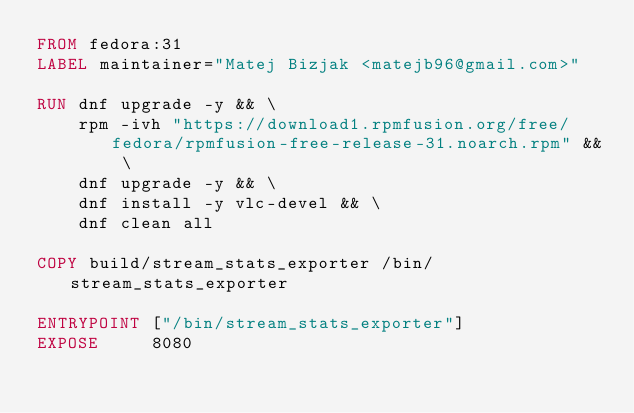Convert code to text. <code><loc_0><loc_0><loc_500><loc_500><_Dockerfile_>FROM fedora:31
LABEL maintainer="Matej Bizjak <matejb96@gmail.com>"

RUN dnf upgrade -y && \
    rpm -ivh "https://download1.rpmfusion.org/free/fedora/rpmfusion-free-release-31.noarch.rpm" && \
    dnf upgrade -y && \
    dnf install -y vlc-devel && \
    dnf clean all

COPY build/stream_stats_exporter /bin/stream_stats_exporter

ENTRYPOINT ["/bin/stream_stats_exporter"]
EXPOSE     8080</code> 